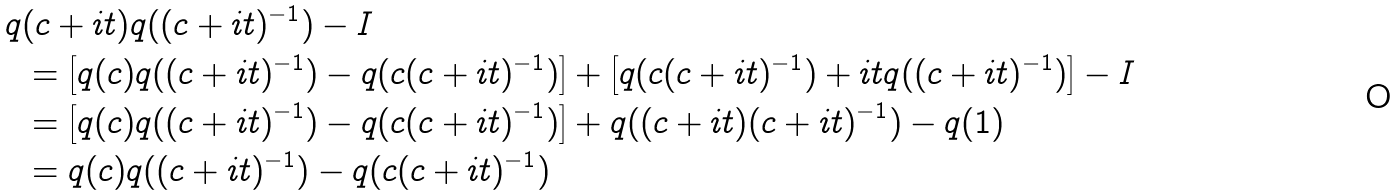Convert formula to latex. <formula><loc_0><loc_0><loc_500><loc_500>q & ( c + i t ) q ( ( c + i t ) ^ { - 1 } ) - I \\ & = \left [ q ( c ) q ( ( c + i t ) ^ { - 1 } ) - q ( c ( c + i t ) ^ { - 1 } ) \right ] + \left [ q ( c ( c + i t ) ^ { - 1 } ) + i t q ( ( c + i t ) ^ { - 1 } ) \right ] - I \\ & = \left [ q ( c ) q ( ( c + i t ) ^ { - 1 } ) - q ( c ( c + i t ) ^ { - 1 } ) \right ] + q ( ( c + i t ) ( c + i t ) ^ { - 1 } ) - q ( 1 ) \\ & = q ( c ) q ( ( c + i t ) ^ { - 1 } ) - q ( c ( c + i t ) ^ { - 1 } )</formula> 